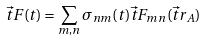<formula> <loc_0><loc_0><loc_500><loc_500>\vec { t } { F } ( t ) = \sum _ { m , n } \sigma _ { n m } ( t ) \vec { t } { F } _ { m n } ( \vec { t } { r } _ { A } )</formula> 